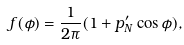Convert formula to latex. <formula><loc_0><loc_0><loc_500><loc_500>f ( \phi ) = \frac { 1 } { 2 \pi } ( 1 + p _ { N } ^ { \prime } \cos \phi ) ,</formula> 